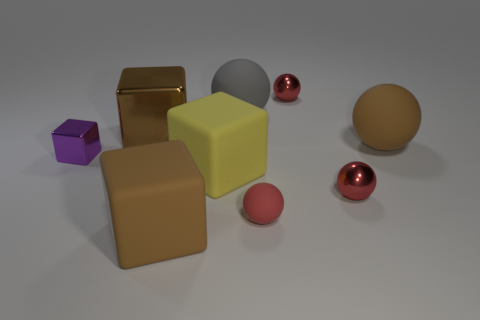Subtract all yellow cubes. How many red spheres are left? 3 Subtract all green balls. Subtract all yellow cylinders. How many balls are left? 5 Subtract all blocks. How many objects are left? 5 Add 1 tiny blocks. How many tiny blocks exist? 2 Subtract 0 cyan cylinders. How many objects are left? 9 Subtract all yellow rubber things. Subtract all brown rubber objects. How many objects are left? 6 Add 3 brown shiny objects. How many brown shiny objects are left? 4 